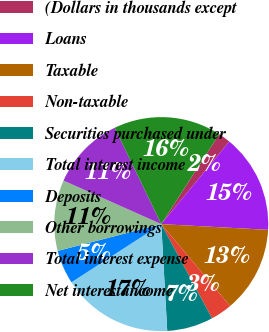<chart> <loc_0><loc_0><loc_500><loc_500><pie_chart><fcel>(Dollars in thousands except<fcel>Loans<fcel>Taxable<fcel>Non-taxable<fcel>Securities purchased under<fcel>Total interest income<fcel>Deposits<fcel>Other borrowings<fcel>Total interest expense<fcel>Net interest income<nl><fcel>1.86%<fcel>14.88%<fcel>13.02%<fcel>3.26%<fcel>6.98%<fcel>16.74%<fcel>5.12%<fcel>10.7%<fcel>11.16%<fcel>16.28%<nl></chart> 